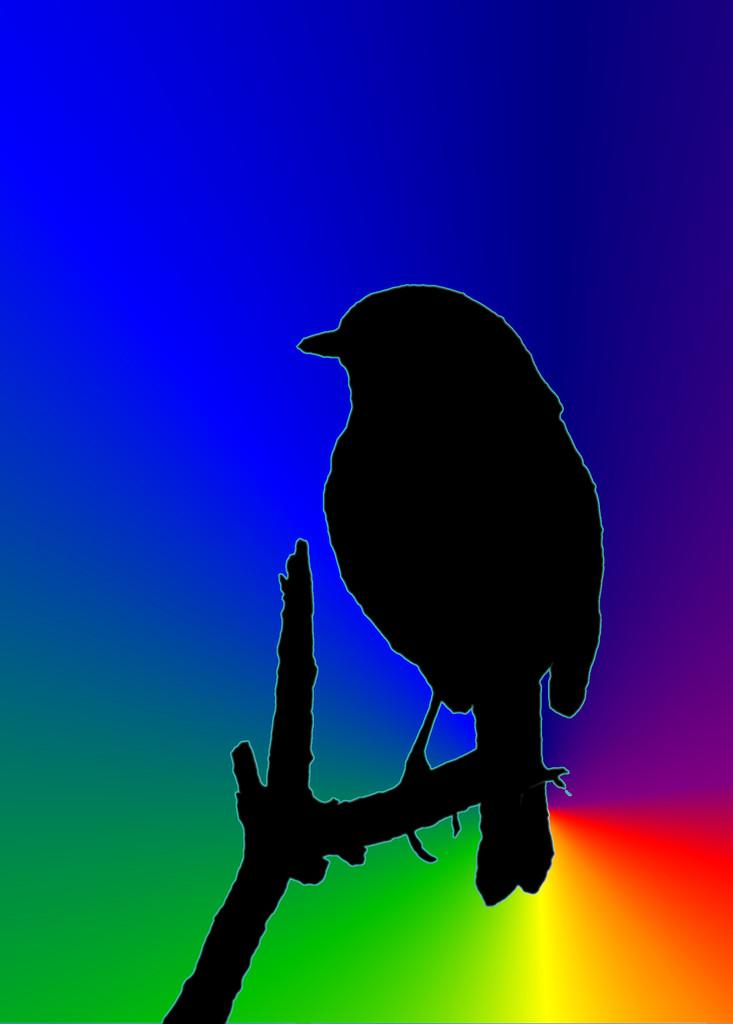What type of animal can be seen in the image? There is a bird in the image. Where is the bird located? The bird is sitting on a tree stem. What can be observed in the background of the image? There are different colors in the background of the image. What type of oil can be seen dripping from the bird in the image? There is no oil present in the image, and the bird is not depicted as dripping anything. 